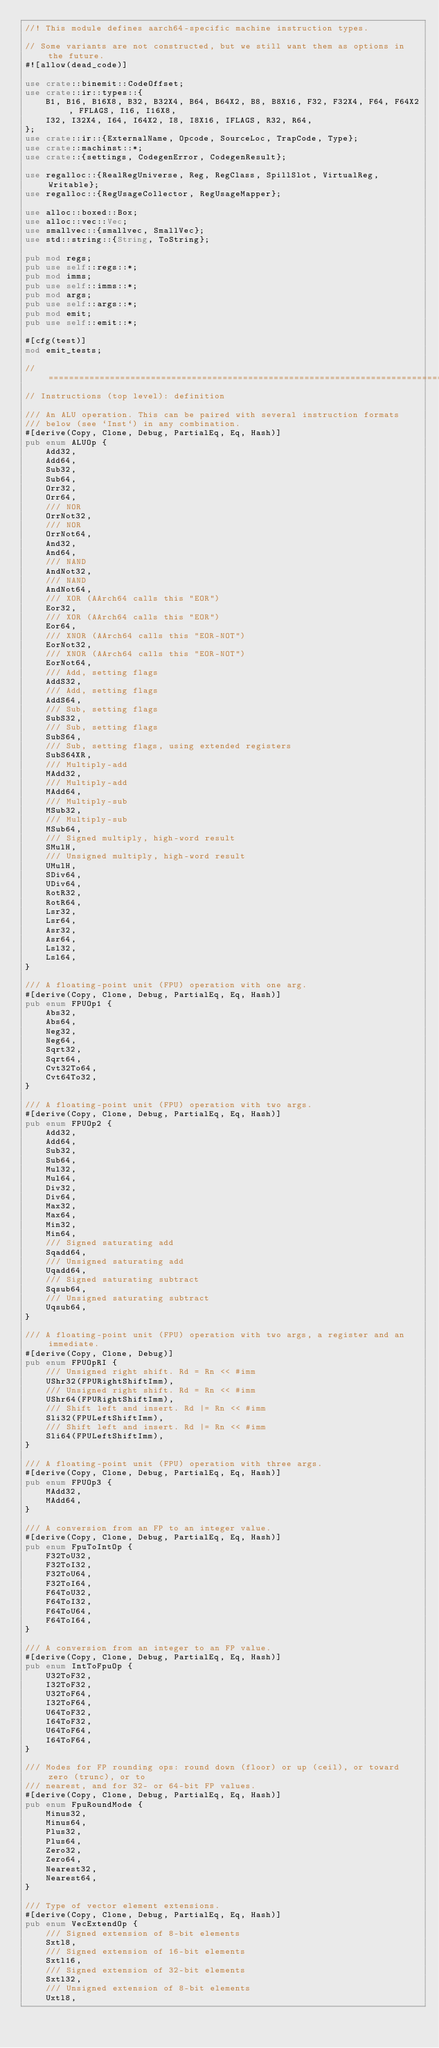<code> <loc_0><loc_0><loc_500><loc_500><_Rust_>//! This module defines aarch64-specific machine instruction types.

// Some variants are not constructed, but we still want them as options in the future.
#![allow(dead_code)]

use crate::binemit::CodeOffset;
use crate::ir::types::{
    B1, B16, B16X8, B32, B32X4, B64, B64X2, B8, B8X16, F32, F32X4, F64, F64X2, FFLAGS, I16, I16X8,
    I32, I32X4, I64, I64X2, I8, I8X16, IFLAGS, R32, R64,
};
use crate::ir::{ExternalName, Opcode, SourceLoc, TrapCode, Type};
use crate::machinst::*;
use crate::{settings, CodegenError, CodegenResult};

use regalloc::{RealRegUniverse, Reg, RegClass, SpillSlot, VirtualReg, Writable};
use regalloc::{RegUsageCollector, RegUsageMapper};

use alloc::boxed::Box;
use alloc::vec::Vec;
use smallvec::{smallvec, SmallVec};
use std::string::{String, ToString};

pub mod regs;
pub use self::regs::*;
pub mod imms;
pub use self::imms::*;
pub mod args;
pub use self::args::*;
pub mod emit;
pub use self::emit::*;

#[cfg(test)]
mod emit_tests;

//=============================================================================
// Instructions (top level): definition

/// An ALU operation. This can be paired with several instruction formats
/// below (see `Inst`) in any combination.
#[derive(Copy, Clone, Debug, PartialEq, Eq, Hash)]
pub enum ALUOp {
    Add32,
    Add64,
    Sub32,
    Sub64,
    Orr32,
    Orr64,
    /// NOR
    OrrNot32,
    /// NOR
    OrrNot64,
    And32,
    And64,
    /// NAND
    AndNot32,
    /// NAND
    AndNot64,
    /// XOR (AArch64 calls this "EOR")
    Eor32,
    /// XOR (AArch64 calls this "EOR")
    Eor64,
    /// XNOR (AArch64 calls this "EOR-NOT")
    EorNot32,
    /// XNOR (AArch64 calls this "EOR-NOT")
    EorNot64,
    /// Add, setting flags
    AddS32,
    /// Add, setting flags
    AddS64,
    /// Sub, setting flags
    SubS32,
    /// Sub, setting flags
    SubS64,
    /// Sub, setting flags, using extended registers
    SubS64XR,
    /// Multiply-add
    MAdd32,
    /// Multiply-add
    MAdd64,
    /// Multiply-sub
    MSub32,
    /// Multiply-sub
    MSub64,
    /// Signed multiply, high-word result
    SMulH,
    /// Unsigned multiply, high-word result
    UMulH,
    SDiv64,
    UDiv64,
    RotR32,
    RotR64,
    Lsr32,
    Lsr64,
    Asr32,
    Asr64,
    Lsl32,
    Lsl64,
}

/// A floating-point unit (FPU) operation with one arg.
#[derive(Copy, Clone, Debug, PartialEq, Eq, Hash)]
pub enum FPUOp1 {
    Abs32,
    Abs64,
    Neg32,
    Neg64,
    Sqrt32,
    Sqrt64,
    Cvt32To64,
    Cvt64To32,
}

/// A floating-point unit (FPU) operation with two args.
#[derive(Copy, Clone, Debug, PartialEq, Eq, Hash)]
pub enum FPUOp2 {
    Add32,
    Add64,
    Sub32,
    Sub64,
    Mul32,
    Mul64,
    Div32,
    Div64,
    Max32,
    Max64,
    Min32,
    Min64,
    /// Signed saturating add
    Sqadd64,
    /// Unsigned saturating add
    Uqadd64,
    /// Signed saturating subtract
    Sqsub64,
    /// Unsigned saturating subtract
    Uqsub64,
}

/// A floating-point unit (FPU) operation with two args, a register and an immediate.
#[derive(Copy, Clone, Debug)]
pub enum FPUOpRI {
    /// Unsigned right shift. Rd = Rn << #imm
    UShr32(FPURightShiftImm),
    /// Unsigned right shift. Rd = Rn << #imm
    UShr64(FPURightShiftImm),
    /// Shift left and insert. Rd |= Rn << #imm
    Sli32(FPULeftShiftImm),
    /// Shift left and insert. Rd |= Rn << #imm
    Sli64(FPULeftShiftImm),
}

/// A floating-point unit (FPU) operation with three args.
#[derive(Copy, Clone, Debug, PartialEq, Eq, Hash)]
pub enum FPUOp3 {
    MAdd32,
    MAdd64,
}

/// A conversion from an FP to an integer value.
#[derive(Copy, Clone, Debug, PartialEq, Eq, Hash)]
pub enum FpuToIntOp {
    F32ToU32,
    F32ToI32,
    F32ToU64,
    F32ToI64,
    F64ToU32,
    F64ToI32,
    F64ToU64,
    F64ToI64,
}

/// A conversion from an integer to an FP value.
#[derive(Copy, Clone, Debug, PartialEq, Eq, Hash)]
pub enum IntToFpuOp {
    U32ToF32,
    I32ToF32,
    U32ToF64,
    I32ToF64,
    U64ToF32,
    I64ToF32,
    U64ToF64,
    I64ToF64,
}

/// Modes for FP rounding ops: round down (floor) or up (ceil), or toward zero (trunc), or to
/// nearest, and for 32- or 64-bit FP values.
#[derive(Copy, Clone, Debug, PartialEq, Eq, Hash)]
pub enum FpuRoundMode {
    Minus32,
    Minus64,
    Plus32,
    Plus64,
    Zero32,
    Zero64,
    Nearest32,
    Nearest64,
}

/// Type of vector element extensions.
#[derive(Copy, Clone, Debug, PartialEq, Eq, Hash)]
pub enum VecExtendOp {
    /// Signed extension of 8-bit elements
    Sxtl8,
    /// Signed extension of 16-bit elements
    Sxtl16,
    /// Signed extension of 32-bit elements
    Sxtl32,
    /// Unsigned extension of 8-bit elements
    Uxtl8,</code> 